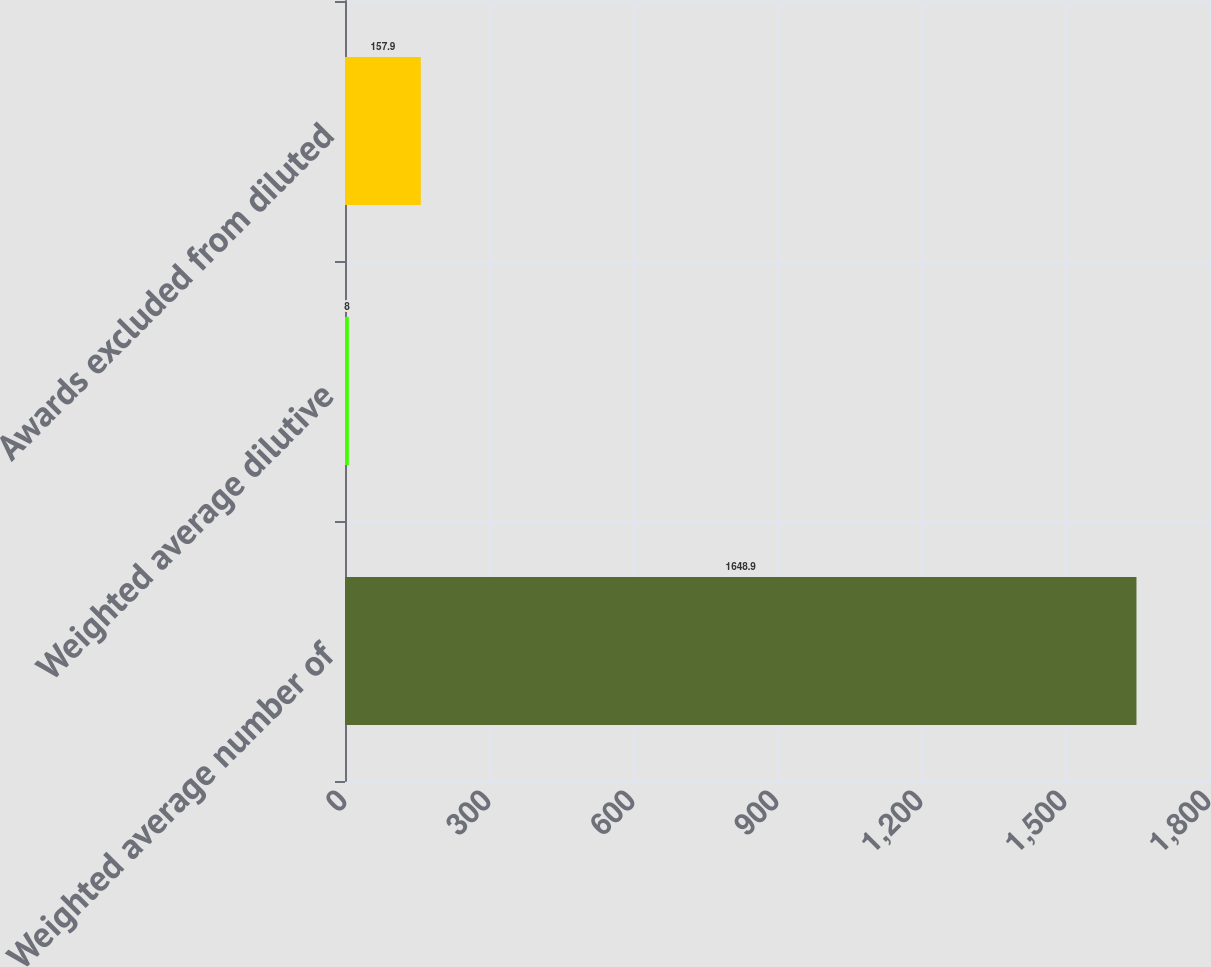<chart> <loc_0><loc_0><loc_500><loc_500><bar_chart><fcel>Weighted average number of<fcel>Weighted average dilutive<fcel>Awards excluded from diluted<nl><fcel>1648.9<fcel>8<fcel>157.9<nl></chart> 